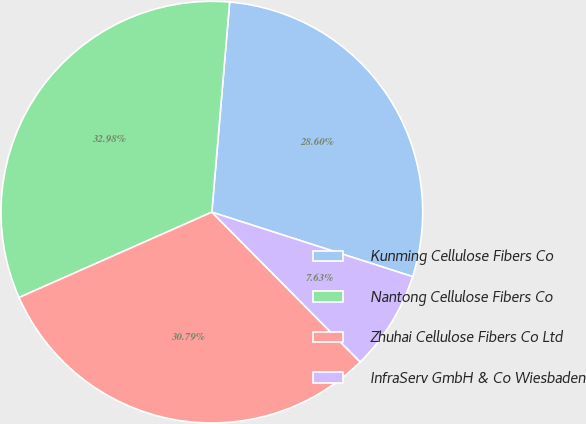Convert chart to OTSL. <chart><loc_0><loc_0><loc_500><loc_500><pie_chart><fcel>Kunming Cellulose Fibers Co<fcel>Nantong Cellulose Fibers Co<fcel>Zhuhai Cellulose Fibers Co Ltd<fcel>InfraServ GmbH & Co Wiesbaden<nl><fcel>28.6%<fcel>32.98%<fcel>30.79%<fcel>7.63%<nl></chart> 